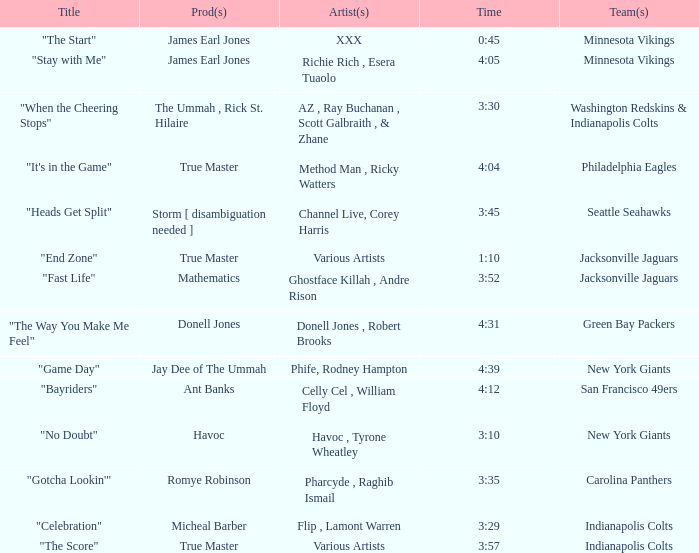How long is the XXX track used by the Minnesota Vikings? 0:45. 